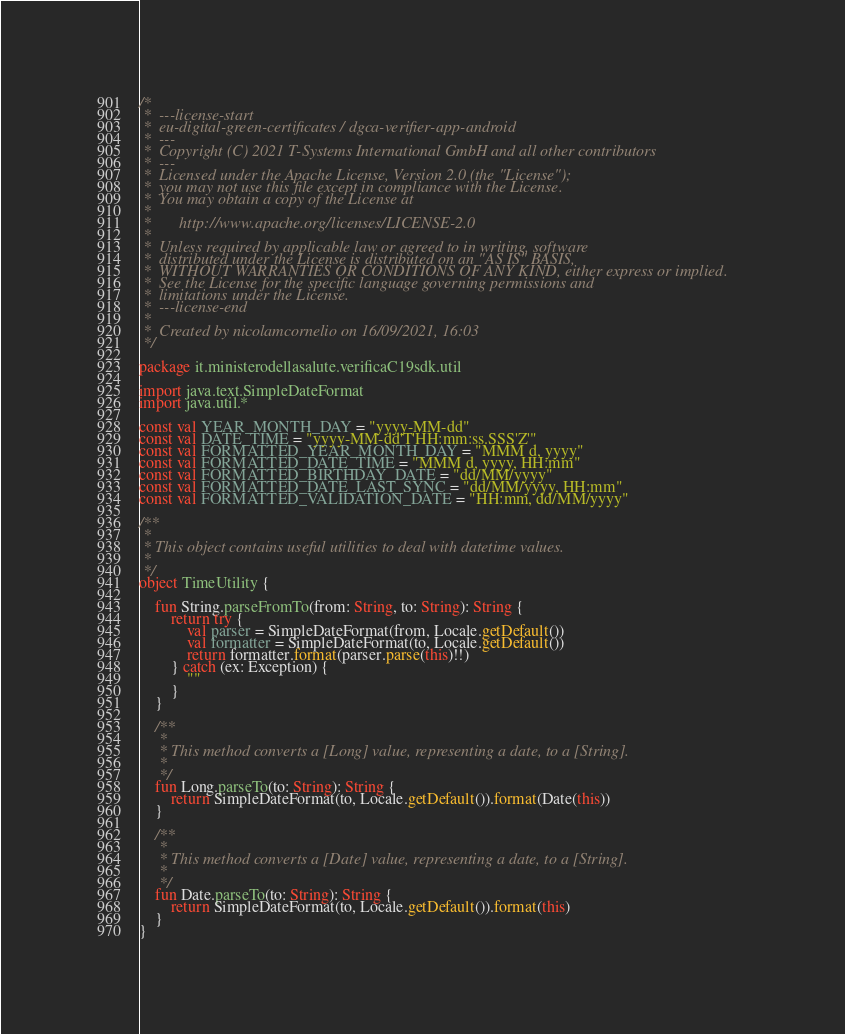<code> <loc_0><loc_0><loc_500><loc_500><_Kotlin_>/*
 *  ---license-start
 *  eu-digital-green-certificates / dgca-verifier-app-android
 *  ---
 *  Copyright (C) 2021 T-Systems International GmbH and all other contributors
 *  ---
 *  Licensed under the Apache License, Version 2.0 (the "License");
 *  you may not use this file except in compliance with the License.
 *  You may obtain a copy of the License at
 *
 *       http://www.apache.org/licenses/LICENSE-2.0
 *
 *  Unless required by applicable law or agreed to in writing, software
 *  distributed under the License is distributed on an "AS IS" BASIS,
 *  WITHOUT WARRANTIES OR CONDITIONS OF ANY KIND, either express or implied.
 *  See the License for the specific language governing permissions and
 *  limitations under the License.
 *  ---license-end
 *
 *  Created by nicolamcornelio on 16/09/2021, 16:03
 */

package it.ministerodellasalute.verificaC19sdk.util

import java.text.SimpleDateFormat
import java.util.*

const val YEAR_MONTH_DAY = "yyyy-MM-dd"
const val DATE_TIME = "yyyy-MM-dd'T'HH:mm:ss.SSS'Z'"
const val FORMATTED_YEAR_MONTH_DAY = "MMM d, yyyy"
const val FORMATTED_DATE_TIME = "MMM d, yyyy, HH:mm"
const val FORMATTED_BIRTHDAY_DATE = "dd/MM/yyyy"
const val FORMATTED_DATE_LAST_SYNC = "dd/MM/yyyy, HH:mm"
const val FORMATTED_VALIDATION_DATE = "HH:mm, dd/MM/yyyy"

/**
 *
 * This object contains useful utilities to deal with datetime values.
 *
 */
object TimeUtility {

    fun String.parseFromTo(from: String, to: String): String {
        return try {
            val parser = SimpleDateFormat(from, Locale.getDefault())
            val formatter = SimpleDateFormat(to, Locale.getDefault())
            return formatter.format(parser.parse(this)!!)
        } catch (ex: Exception) {
            ""
        }
    }

    /**
     *
     * This method converts a [Long] value, representing a date, to a [String].
     *
     */
    fun Long.parseTo(to: String): String {
        return SimpleDateFormat(to, Locale.getDefault()).format(Date(this))
    }

    /**
     *
     * This method converts a [Date] value, representing a date, to a [String].
     *
     */
    fun Date.parseTo(to: String): String {
        return SimpleDateFormat(to, Locale.getDefault()).format(this)
    }
}</code> 